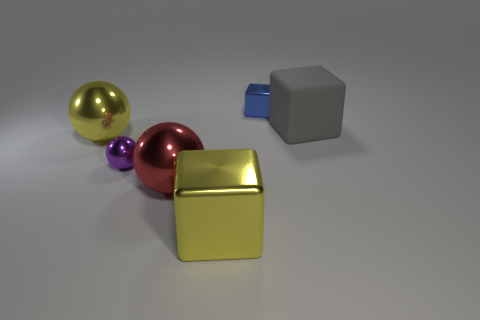Add 4 small blue objects. How many objects exist? 10 Add 2 gray objects. How many gray objects are left? 3 Add 5 gray metal cylinders. How many gray metal cylinders exist? 5 Subtract 1 yellow blocks. How many objects are left? 5 Subtract all yellow shiny blocks. Subtract all small purple objects. How many objects are left? 4 